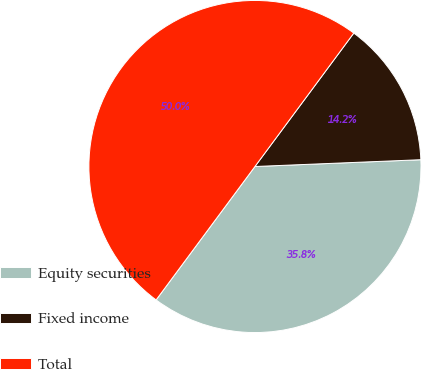Convert chart. <chart><loc_0><loc_0><loc_500><loc_500><pie_chart><fcel>Equity securities<fcel>Fixed income<fcel>Total<nl><fcel>35.8%<fcel>14.2%<fcel>50.0%<nl></chart> 